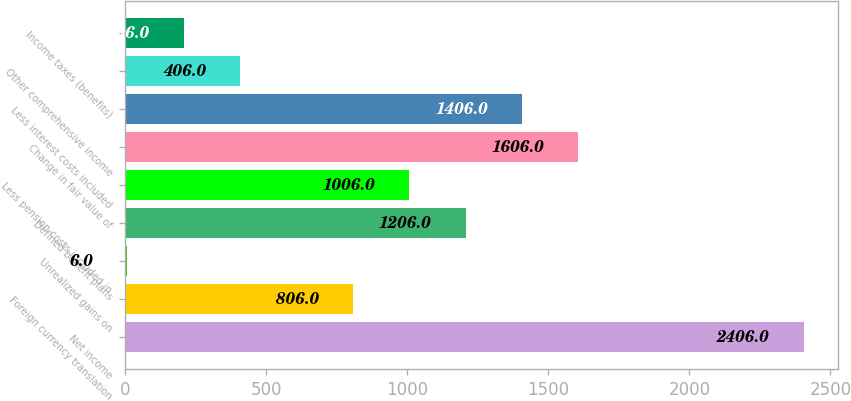<chart> <loc_0><loc_0><loc_500><loc_500><bar_chart><fcel>Net income<fcel>Foreign currency translation<fcel>Unrealized gains on<fcel>Defined benefit plans<fcel>Less pension costs included in<fcel>Change in fair value of<fcel>Less interest costs included<fcel>Other comprehensive income<fcel>Income taxes (benefits)<nl><fcel>2406<fcel>806<fcel>6<fcel>1206<fcel>1006<fcel>1606<fcel>1406<fcel>406<fcel>206<nl></chart> 